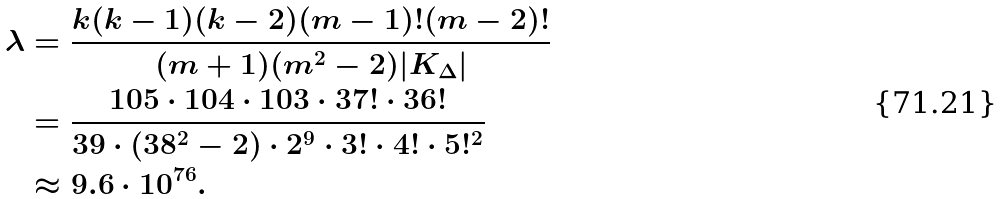<formula> <loc_0><loc_0><loc_500><loc_500>\lambda & = \frac { k ( k - 1 ) ( k - 2 ) ( m - 1 ) ! ( m - 2 ) ! } { ( m + 1 ) ( m ^ { 2 } - 2 ) | K _ { \Delta } | } \\ & = \frac { 1 0 5 \cdot 1 0 4 \cdot 1 0 3 \cdot 3 7 ! \cdot 3 6 ! } { 3 9 \cdot ( 3 8 ^ { 2 } - 2 ) \cdot 2 ^ { 9 } \cdot 3 ! \cdot 4 ! \cdot 5 ! ^ { 2 } } \\ & \approx 9 . 6 \cdot 1 0 ^ { 7 6 } .</formula> 